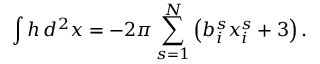<formula> <loc_0><loc_0><loc_500><loc_500>\int h \, d ^ { 2 } x = - 2 \pi \sum _ { s = 1 } ^ { N } \left ( b _ { i } ^ { s } x _ { i } ^ { s } + 3 \right ) .</formula> 